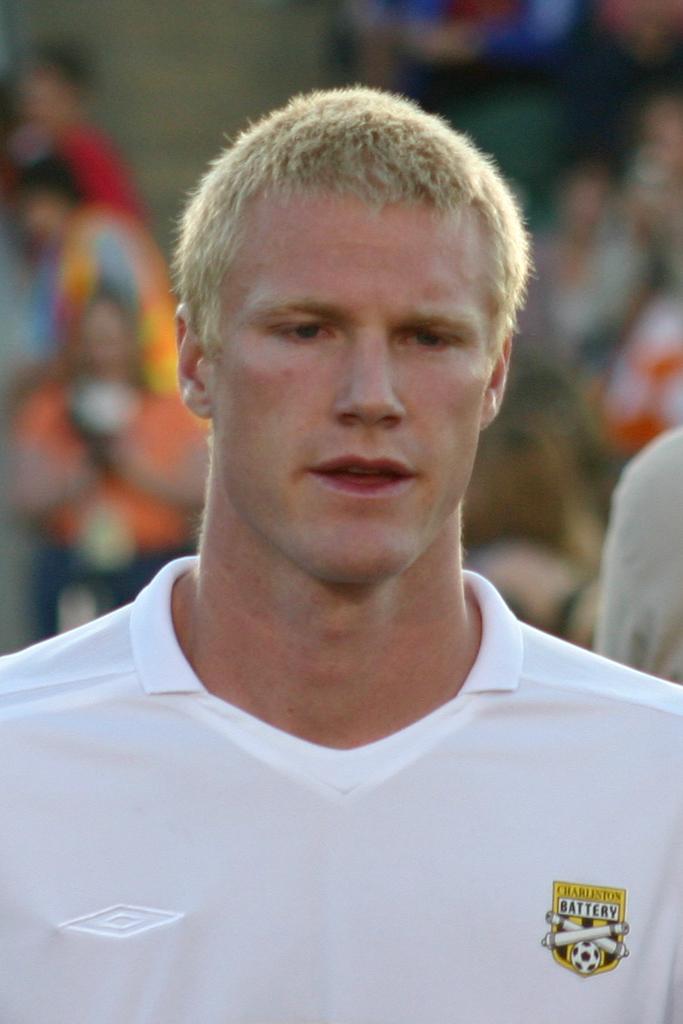What is the name of the team on the shirt?
Your answer should be compact. Charleston battery. 